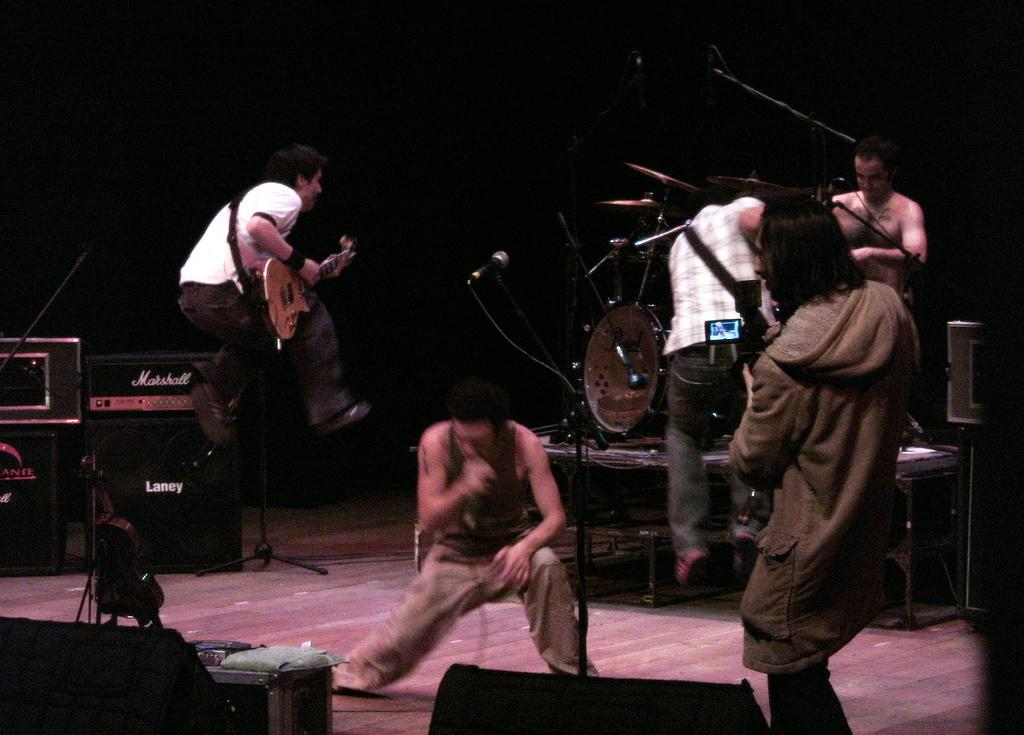What is happening in the image? There is a group of people in the image, and they are playing musical instruments. Where are the people located in the image? The people are standing on a stage. What can be seen in the background of the image? There are lights visible in the background of the image. What type of food is the cook preparing for the visitor in the image? There is no cook or visitor present in the image; it features a group of people playing musical instruments on a stage. How does the attack occur in the image? There is no attack or any indication of violence in the image; it shows a peaceful scene of people playing music on a stage. 